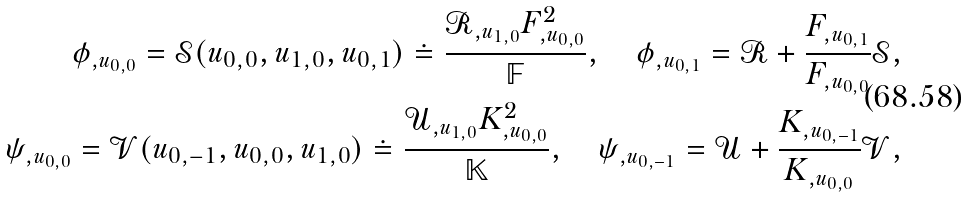Convert formula to latex. <formula><loc_0><loc_0><loc_500><loc_500>\phi _ { , u _ { 0 , 0 } } = \mathcal { S } ( u _ { 0 , 0 } , u _ { 1 , 0 } , u _ { 0 , 1 } ) \doteq \frac { \mathcal { R } _ { , u _ { 1 , 0 } } F _ { , u _ { 0 , 0 } } ^ { 2 } } { \mathbb { F } } , \quad \phi _ { , u _ { 0 , 1 } } = \mathcal { R } + \frac { F _ { , u _ { 0 , 1 } } } { F _ { , u _ { 0 , 0 } } } \mathcal { S } , \\ \psi _ { , u _ { 0 , 0 } } = \mathcal { V } ( u _ { 0 , - 1 } , u _ { 0 , 0 } , u _ { 1 , 0 } ) \doteq \frac { \mathcal { U } _ { , u _ { 1 , 0 } } K _ { , u _ { 0 , 0 } } ^ { 2 } } { \mathbb { K } } , \quad \psi _ { , u _ { 0 , - 1 } } = \mathcal { U } + \frac { K _ { , u _ { 0 , - 1 } } } { K _ { , u _ { 0 , 0 } } } \mathcal { V } ,</formula> 